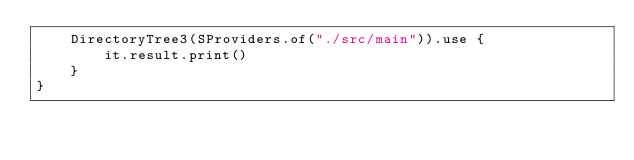Convert code to text. <code><loc_0><loc_0><loc_500><loc_500><_Kotlin_>    DirectoryTree3(SProviders.of("./src/main")).use {
        it.result.print()
    }
}


</code> 